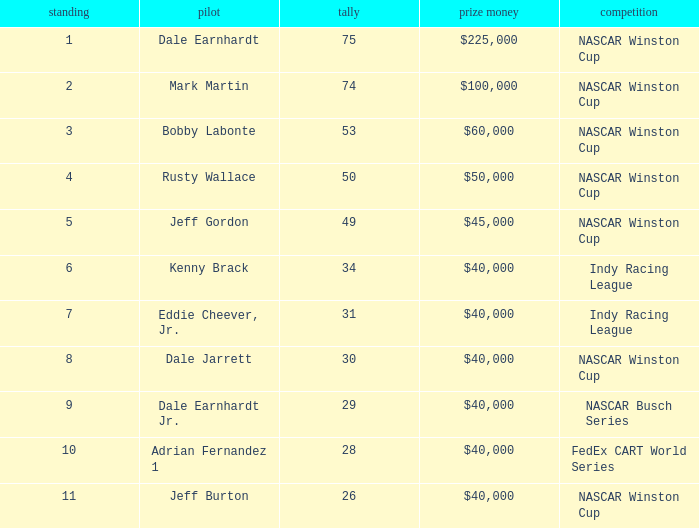In what position was the driver who won $60,000? 3.0. 